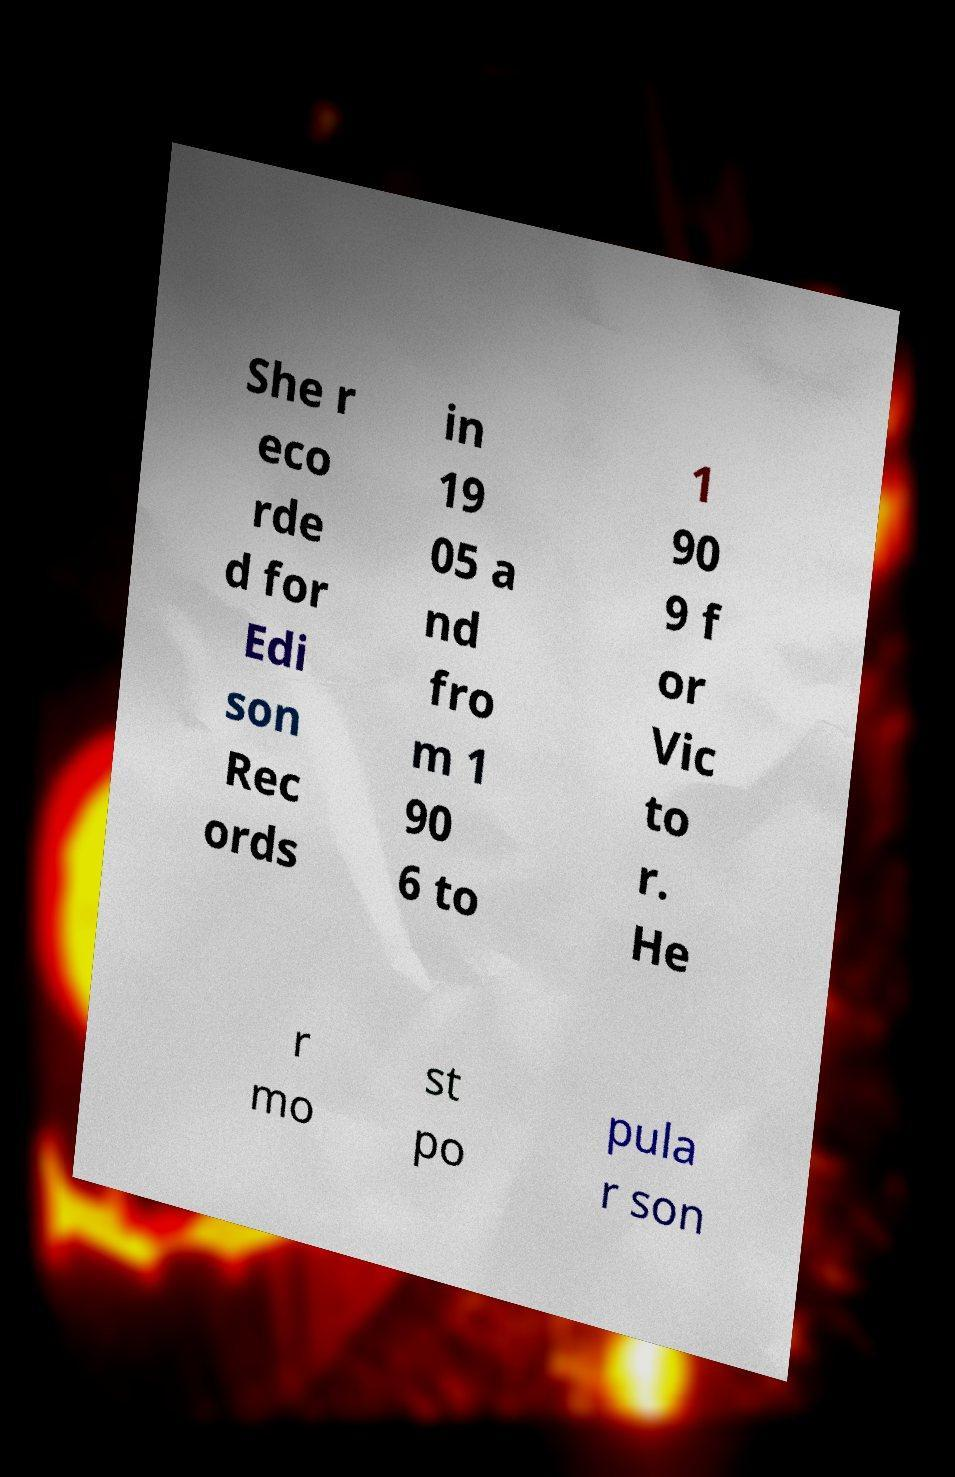Please identify and transcribe the text found in this image. She r eco rde d for Edi son Rec ords in 19 05 a nd fro m 1 90 6 to 1 90 9 f or Vic to r. He r mo st po pula r son 